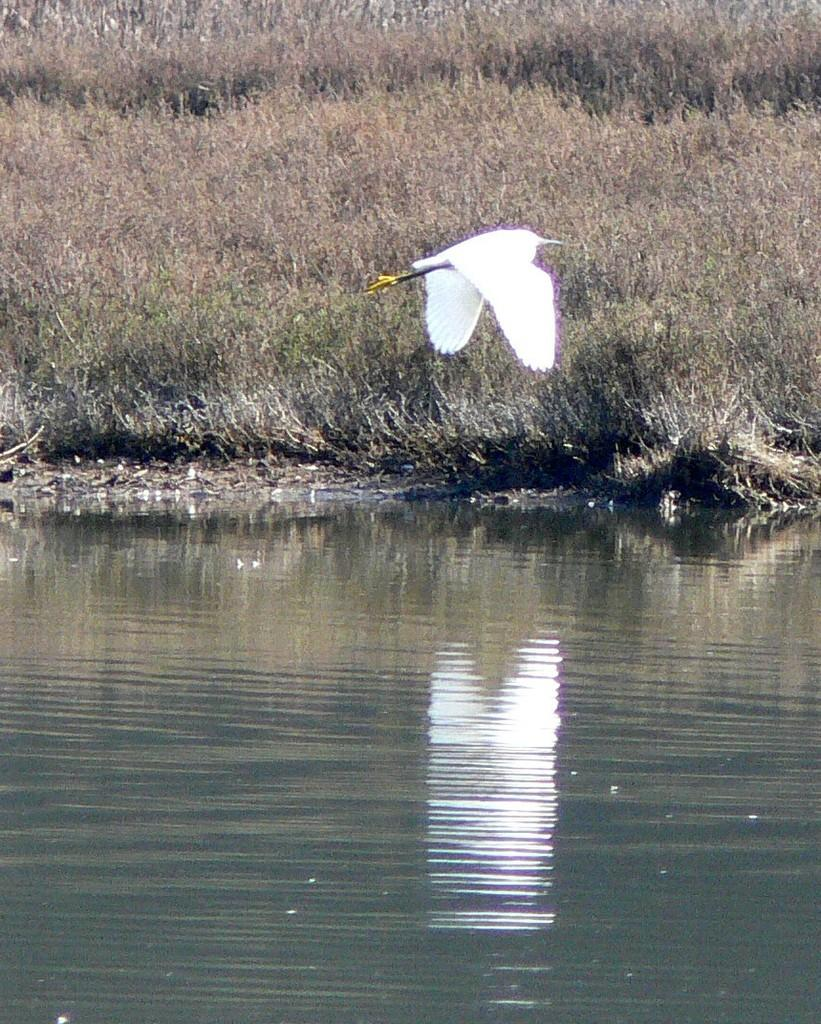What is the bird doing in the image? The bird is flying in the air with wings. Where is the bird located in relation to the water? The bird is above the water. What can be seen in the background of the image? There are dried plants in the background of the image. What type of leather is visible on the bird's wings in the image? There is no leather present on the bird's wings in the image; the bird's wings are made of feathers. What time of day is depicted in the image? The provided facts do not give information about the time of day, so it cannot be determined from the image. 